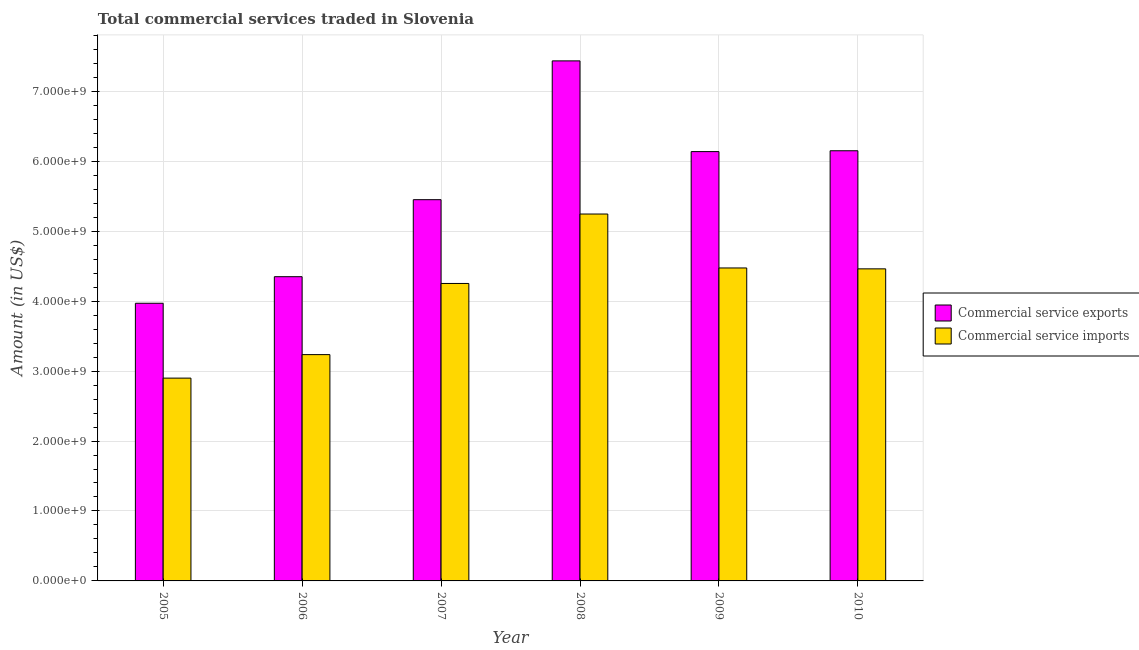What is the amount of commercial service exports in 2009?
Ensure brevity in your answer.  6.14e+09. Across all years, what is the maximum amount of commercial service imports?
Offer a very short reply. 5.25e+09. Across all years, what is the minimum amount of commercial service exports?
Provide a short and direct response. 3.97e+09. In which year was the amount of commercial service imports minimum?
Your answer should be very brief. 2005. What is the total amount of commercial service imports in the graph?
Offer a very short reply. 2.46e+1. What is the difference between the amount of commercial service imports in 2005 and that in 2007?
Offer a very short reply. -1.35e+09. What is the difference between the amount of commercial service exports in 2006 and the amount of commercial service imports in 2010?
Ensure brevity in your answer.  -1.80e+09. What is the average amount of commercial service exports per year?
Your response must be concise. 5.58e+09. In the year 2006, what is the difference between the amount of commercial service exports and amount of commercial service imports?
Offer a very short reply. 0. In how many years, is the amount of commercial service exports greater than 6000000000 US$?
Give a very brief answer. 3. What is the ratio of the amount of commercial service exports in 2006 to that in 2009?
Give a very brief answer. 0.71. Is the amount of commercial service exports in 2007 less than that in 2009?
Your answer should be compact. Yes. What is the difference between the highest and the second highest amount of commercial service exports?
Your answer should be compact. 1.29e+09. What is the difference between the highest and the lowest amount of commercial service exports?
Provide a succinct answer. 3.47e+09. Is the sum of the amount of commercial service imports in 2006 and 2008 greater than the maximum amount of commercial service exports across all years?
Make the answer very short. Yes. What does the 1st bar from the left in 2008 represents?
Keep it short and to the point. Commercial service exports. What does the 2nd bar from the right in 2010 represents?
Give a very brief answer. Commercial service exports. How many bars are there?
Ensure brevity in your answer.  12. Are all the bars in the graph horizontal?
Your answer should be compact. No. Are the values on the major ticks of Y-axis written in scientific E-notation?
Your answer should be very brief. Yes. Does the graph contain any zero values?
Make the answer very short. No. Does the graph contain grids?
Provide a succinct answer. Yes. How many legend labels are there?
Your answer should be compact. 2. What is the title of the graph?
Give a very brief answer. Total commercial services traded in Slovenia. What is the label or title of the Y-axis?
Provide a short and direct response. Amount (in US$). What is the Amount (in US$) in Commercial service exports in 2005?
Give a very brief answer. 3.97e+09. What is the Amount (in US$) in Commercial service imports in 2005?
Your answer should be compact. 2.90e+09. What is the Amount (in US$) in Commercial service exports in 2006?
Make the answer very short. 4.35e+09. What is the Amount (in US$) of Commercial service imports in 2006?
Ensure brevity in your answer.  3.24e+09. What is the Amount (in US$) in Commercial service exports in 2007?
Your response must be concise. 5.45e+09. What is the Amount (in US$) in Commercial service imports in 2007?
Offer a very short reply. 4.25e+09. What is the Amount (in US$) in Commercial service exports in 2008?
Keep it short and to the point. 7.43e+09. What is the Amount (in US$) of Commercial service imports in 2008?
Ensure brevity in your answer.  5.25e+09. What is the Amount (in US$) of Commercial service exports in 2009?
Make the answer very short. 6.14e+09. What is the Amount (in US$) of Commercial service imports in 2009?
Keep it short and to the point. 4.47e+09. What is the Amount (in US$) in Commercial service exports in 2010?
Provide a succinct answer. 6.15e+09. What is the Amount (in US$) in Commercial service imports in 2010?
Offer a terse response. 4.46e+09. Across all years, what is the maximum Amount (in US$) of Commercial service exports?
Ensure brevity in your answer.  7.43e+09. Across all years, what is the maximum Amount (in US$) of Commercial service imports?
Your response must be concise. 5.25e+09. Across all years, what is the minimum Amount (in US$) in Commercial service exports?
Give a very brief answer. 3.97e+09. Across all years, what is the minimum Amount (in US$) in Commercial service imports?
Provide a short and direct response. 2.90e+09. What is the total Amount (in US$) in Commercial service exports in the graph?
Ensure brevity in your answer.  3.35e+1. What is the total Amount (in US$) in Commercial service imports in the graph?
Make the answer very short. 2.46e+1. What is the difference between the Amount (in US$) of Commercial service exports in 2005 and that in 2006?
Your answer should be very brief. -3.80e+08. What is the difference between the Amount (in US$) of Commercial service imports in 2005 and that in 2006?
Your response must be concise. -3.36e+08. What is the difference between the Amount (in US$) of Commercial service exports in 2005 and that in 2007?
Your response must be concise. -1.48e+09. What is the difference between the Amount (in US$) of Commercial service imports in 2005 and that in 2007?
Make the answer very short. -1.35e+09. What is the difference between the Amount (in US$) in Commercial service exports in 2005 and that in 2008?
Your response must be concise. -3.47e+09. What is the difference between the Amount (in US$) in Commercial service imports in 2005 and that in 2008?
Your answer should be compact. -2.35e+09. What is the difference between the Amount (in US$) of Commercial service exports in 2005 and that in 2009?
Keep it short and to the point. -2.17e+09. What is the difference between the Amount (in US$) in Commercial service imports in 2005 and that in 2009?
Give a very brief answer. -1.57e+09. What is the difference between the Amount (in US$) in Commercial service exports in 2005 and that in 2010?
Your answer should be compact. -2.18e+09. What is the difference between the Amount (in US$) of Commercial service imports in 2005 and that in 2010?
Your answer should be compact. -1.56e+09. What is the difference between the Amount (in US$) in Commercial service exports in 2006 and that in 2007?
Keep it short and to the point. -1.10e+09. What is the difference between the Amount (in US$) in Commercial service imports in 2006 and that in 2007?
Offer a very short reply. -1.02e+09. What is the difference between the Amount (in US$) in Commercial service exports in 2006 and that in 2008?
Offer a terse response. -3.09e+09. What is the difference between the Amount (in US$) of Commercial service imports in 2006 and that in 2008?
Your answer should be compact. -2.01e+09. What is the difference between the Amount (in US$) in Commercial service exports in 2006 and that in 2009?
Your answer should be very brief. -1.79e+09. What is the difference between the Amount (in US$) of Commercial service imports in 2006 and that in 2009?
Provide a short and direct response. -1.24e+09. What is the difference between the Amount (in US$) in Commercial service exports in 2006 and that in 2010?
Provide a short and direct response. -1.80e+09. What is the difference between the Amount (in US$) in Commercial service imports in 2006 and that in 2010?
Provide a succinct answer. -1.23e+09. What is the difference between the Amount (in US$) in Commercial service exports in 2007 and that in 2008?
Your answer should be very brief. -1.98e+09. What is the difference between the Amount (in US$) in Commercial service imports in 2007 and that in 2008?
Ensure brevity in your answer.  -9.93e+08. What is the difference between the Amount (in US$) of Commercial service exports in 2007 and that in 2009?
Keep it short and to the point. -6.87e+08. What is the difference between the Amount (in US$) of Commercial service imports in 2007 and that in 2009?
Keep it short and to the point. -2.22e+08. What is the difference between the Amount (in US$) of Commercial service exports in 2007 and that in 2010?
Your response must be concise. -6.99e+08. What is the difference between the Amount (in US$) of Commercial service imports in 2007 and that in 2010?
Provide a succinct answer. -2.09e+08. What is the difference between the Amount (in US$) in Commercial service exports in 2008 and that in 2009?
Your answer should be very brief. 1.30e+09. What is the difference between the Amount (in US$) in Commercial service imports in 2008 and that in 2009?
Your response must be concise. 7.71e+08. What is the difference between the Amount (in US$) of Commercial service exports in 2008 and that in 2010?
Provide a succinct answer. 1.29e+09. What is the difference between the Amount (in US$) of Commercial service imports in 2008 and that in 2010?
Your answer should be compact. 7.84e+08. What is the difference between the Amount (in US$) in Commercial service exports in 2009 and that in 2010?
Provide a short and direct response. -1.21e+07. What is the difference between the Amount (in US$) of Commercial service imports in 2009 and that in 2010?
Ensure brevity in your answer.  1.28e+07. What is the difference between the Amount (in US$) of Commercial service exports in 2005 and the Amount (in US$) of Commercial service imports in 2006?
Provide a short and direct response. 7.34e+08. What is the difference between the Amount (in US$) of Commercial service exports in 2005 and the Amount (in US$) of Commercial service imports in 2007?
Provide a short and direct response. -2.83e+08. What is the difference between the Amount (in US$) of Commercial service exports in 2005 and the Amount (in US$) of Commercial service imports in 2008?
Offer a terse response. -1.28e+09. What is the difference between the Amount (in US$) of Commercial service exports in 2005 and the Amount (in US$) of Commercial service imports in 2009?
Provide a succinct answer. -5.05e+08. What is the difference between the Amount (in US$) of Commercial service exports in 2005 and the Amount (in US$) of Commercial service imports in 2010?
Offer a terse response. -4.92e+08. What is the difference between the Amount (in US$) of Commercial service exports in 2006 and the Amount (in US$) of Commercial service imports in 2007?
Make the answer very short. 9.68e+07. What is the difference between the Amount (in US$) of Commercial service exports in 2006 and the Amount (in US$) of Commercial service imports in 2008?
Give a very brief answer. -8.96e+08. What is the difference between the Amount (in US$) in Commercial service exports in 2006 and the Amount (in US$) in Commercial service imports in 2009?
Make the answer very short. -1.25e+08. What is the difference between the Amount (in US$) of Commercial service exports in 2006 and the Amount (in US$) of Commercial service imports in 2010?
Provide a succinct answer. -1.12e+08. What is the difference between the Amount (in US$) in Commercial service exports in 2007 and the Amount (in US$) in Commercial service imports in 2008?
Keep it short and to the point. 2.05e+08. What is the difference between the Amount (in US$) in Commercial service exports in 2007 and the Amount (in US$) in Commercial service imports in 2009?
Your response must be concise. 9.76e+08. What is the difference between the Amount (in US$) in Commercial service exports in 2007 and the Amount (in US$) in Commercial service imports in 2010?
Provide a short and direct response. 9.89e+08. What is the difference between the Amount (in US$) in Commercial service exports in 2008 and the Amount (in US$) in Commercial service imports in 2009?
Your answer should be very brief. 2.96e+09. What is the difference between the Amount (in US$) of Commercial service exports in 2008 and the Amount (in US$) of Commercial service imports in 2010?
Your response must be concise. 2.97e+09. What is the difference between the Amount (in US$) of Commercial service exports in 2009 and the Amount (in US$) of Commercial service imports in 2010?
Your answer should be very brief. 1.68e+09. What is the average Amount (in US$) of Commercial service exports per year?
Ensure brevity in your answer.  5.58e+09. What is the average Amount (in US$) in Commercial service imports per year?
Offer a very short reply. 4.09e+09. In the year 2005, what is the difference between the Amount (in US$) of Commercial service exports and Amount (in US$) of Commercial service imports?
Provide a short and direct response. 1.07e+09. In the year 2006, what is the difference between the Amount (in US$) of Commercial service exports and Amount (in US$) of Commercial service imports?
Keep it short and to the point. 1.11e+09. In the year 2007, what is the difference between the Amount (in US$) in Commercial service exports and Amount (in US$) in Commercial service imports?
Your response must be concise. 1.20e+09. In the year 2008, what is the difference between the Amount (in US$) in Commercial service exports and Amount (in US$) in Commercial service imports?
Make the answer very short. 2.19e+09. In the year 2009, what is the difference between the Amount (in US$) in Commercial service exports and Amount (in US$) in Commercial service imports?
Make the answer very short. 1.66e+09. In the year 2010, what is the difference between the Amount (in US$) of Commercial service exports and Amount (in US$) of Commercial service imports?
Give a very brief answer. 1.69e+09. What is the ratio of the Amount (in US$) in Commercial service exports in 2005 to that in 2006?
Your response must be concise. 0.91. What is the ratio of the Amount (in US$) of Commercial service imports in 2005 to that in 2006?
Your answer should be very brief. 0.9. What is the ratio of the Amount (in US$) of Commercial service exports in 2005 to that in 2007?
Provide a succinct answer. 0.73. What is the ratio of the Amount (in US$) of Commercial service imports in 2005 to that in 2007?
Offer a terse response. 0.68. What is the ratio of the Amount (in US$) in Commercial service exports in 2005 to that in 2008?
Offer a very short reply. 0.53. What is the ratio of the Amount (in US$) of Commercial service imports in 2005 to that in 2008?
Ensure brevity in your answer.  0.55. What is the ratio of the Amount (in US$) in Commercial service exports in 2005 to that in 2009?
Provide a succinct answer. 0.65. What is the ratio of the Amount (in US$) of Commercial service imports in 2005 to that in 2009?
Keep it short and to the point. 0.65. What is the ratio of the Amount (in US$) of Commercial service exports in 2005 to that in 2010?
Ensure brevity in your answer.  0.65. What is the ratio of the Amount (in US$) of Commercial service imports in 2005 to that in 2010?
Provide a short and direct response. 0.65. What is the ratio of the Amount (in US$) in Commercial service exports in 2006 to that in 2007?
Offer a terse response. 0.8. What is the ratio of the Amount (in US$) of Commercial service imports in 2006 to that in 2007?
Offer a very short reply. 0.76. What is the ratio of the Amount (in US$) in Commercial service exports in 2006 to that in 2008?
Your answer should be very brief. 0.58. What is the ratio of the Amount (in US$) of Commercial service imports in 2006 to that in 2008?
Offer a very short reply. 0.62. What is the ratio of the Amount (in US$) of Commercial service exports in 2006 to that in 2009?
Offer a terse response. 0.71. What is the ratio of the Amount (in US$) of Commercial service imports in 2006 to that in 2009?
Make the answer very short. 0.72. What is the ratio of the Amount (in US$) of Commercial service exports in 2006 to that in 2010?
Give a very brief answer. 0.71. What is the ratio of the Amount (in US$) of Commercial service imports in 2006 to that in 2010?
Offer a very short reply. 0.73. What is the ratio of the Amount (in US$) in Commercial service exports in 2007 to that in 2008?
Provide a short and direct response. 0.73. What is the ratio of the Amount (in US$) of Commercial service imports in 2007 to that in 2008?
Provide a succinct answer. 0.81. What is the ratio of the Amount (in US$) in Commercial service exports in 2007 to that in 2009?
Your response must be concise. 0.89. What is the ratio of the Amount (in US$) in Commercial service imports in 2007 to that in 2009?
Your response must be concise. 0.95. What is the ratio of the Amount (in US$) of Commercial service exports in 2007 to that in 2010?
Offer a terse response. 0.89. What is the ratio of the Amount (in US$) in Commercial service imports in 2007 to that in 2010?
Ensure brevity in your answer.  0.95. What is the ratio of the Amount (in US$) of Commercial service exports in 2008 to that in 2009?
Ensure brevity in your answer.  1.21. What is the ratio of the Amount (in US$) of Commercial service imports in 2008 to that in 2009?
Your answer should be compact. 1.17. What is the ratio of the Amount (in US$) in Commercial service exports in 2008 to that in 2010?
Keep it short and to the point. 1.21. What is the ratio of the Amount (in US$) of Commercial service imports in 2008 to that in 2010?
Your response must be concise. 1.18. What is the ratio of the Amount (in US$) in Commercial service exports in 2009 to that in 2010?
Make the answer very short. 1. What is the difference between the highest and the second highest Amount (in US$) of Commercial service exports?
Provide a short and direct response. 1.29e+09. What is the difference between the highest and the second highest Amount (in US$) in Commercial service imports?
Offer a very short reply. 7.71e+08. What is the difference between the highest and the lowest Amount (in US$) of Commercial service exports?
Offer a terse response. 3.47e+09. What is the difference between the highest and the lowest Amount (in US$) of Commercial service imports?
Ensure brevity in your answer.  2.35e+09. 